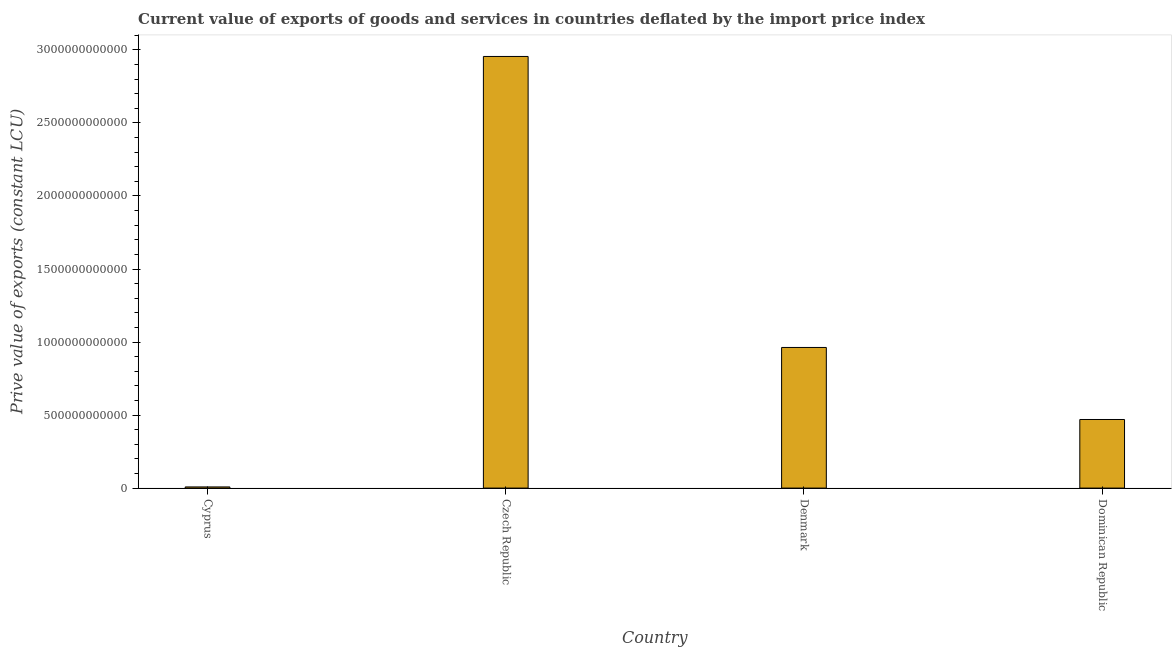Does the graph contain any zero values?
Make the answer very short. No. What is the title of the graph?
Offer a very short reply. Current value of exports of goods and services in countries deflated by the import price index. What is the label or title of the Y-axis?
Ensure brevity in your answer.  Prive value of exports (constant LCU). What is the price value of exports in Dominican Republic?
Keep it short and to the point. 4.70e+11. Across all countries, what is the maximum price value of exports?
Make the answer very short. 2.96e+12. Across all countries, what is the minimum price value of exports?
Your response must be concise. 7.92e+09. In which country was the price value of exports maximum?
Offer a terse response. Czech Republic. In which country was the price value of exports minimum?
Your answer should be compact. Cyprus. What is the sum of the price value of exports?
Make the answer very short. 4.40e+12. What is the difference between the price value of exports in Cyprus and Denmark?
Your response must be concise. -9.55e+11. What is the average price value of exports per country?
Offer a very short reply. 1.10e+12. What is the median price value of exports?
Your answer should be very brief. 7.16e+11. In how many countries, is the price value of exports greater than 1000000000000 LCU?
Make the answer very short. 1. What is the ratio of the price value of exports in Cyprus to that in Denmark?
Ensure brevity in your answer.  0.01. Is the price value of exports in Cyprus less than that in Dominican Republic?
Ensure brevity in your answer.  Yes. Is the difference between the price value of exports in Czech Republic and Denmark greater than the difference between any two countries?
Ensure brevity in your answer.  No. What is the difference between the highest and the second highest price value of exports?
Your response must be concise. 1.99e+12. Is the sum of the price value of exports in Denmark and Dominican Republic greater than the maximum price value of exports across all countries?
Your answer should be compact. No. What is the difference between the highest and the lowest price value of exports?
Your answer should be very brief. 2.95e+12. Are all the bars in the graph horizontal?
Provide a short and direct response. No. How many countries are there in the graph?
Give a very brief answer. 4. What is the difference between two consecutive major ticks on the Y-axis?
Ensure brevity in your answer.  5.00e+11. What is the Prive value of exports (constant LCU) of Cyprus?
Ensure brevity in your answer.  7.92e+09. What is the Prive value of exports (constant LCU) of Czech Republic?
Offer a very short reply. 2.96e+12. What is the Prive value of exports (constant LCU) in Denmark?
Keep it short and to the point. 9.63e+11. What is the Prive value of exports (constant LCU) in Dominican Republic?
Ensure brevity in your answer.  4.70e+11. What is the difference between the Prive value of exports (constant LCU) in Cyprus and Czech Republic?
Ensure brevity in your answer.  -2.95e+12. What is the difference between the Prive value of exports (constant LCU) in Cyprus and Denmark?
Give a very brief answer. -9.55e+11. What is the difference between the Prive value of exports (constant LCU) in Cyprus and Dominican Republic?
Your answer should be compact. -4.62e+11. What is the difference between the Prive value of exports (constant LCU) in Czech Republic and Denmark?
Your response must be concise. 1.99e+12. What is the difference between the Prive value of exports (constant LCU) in Czech Republic and Dominican Republic?
Your response must be concise. 2.49e+12. What is the difference between the Prive value of exports (constant LCU) in Denmark and Dominican Republic?
Your response must be concise. 4.93e+11. What is the ratio of the Prive value of exports (constant LCU) in Cyprus to that in Czech Republic?
Offer a very short reply. 0. What is the ratio of the Prive value of exports (constant LCU) in Cyprus to that in Denmark?
Provide a succinct answer. 0.01. What is the ratio of the Prive value of exports (constant LCU) in Cyprus to that in Dominican Republic?
Give a very brief answer. 0.02. What is the ratio of the Prive value of exports (constant LCU) in Czech Republic to that in Denmark?
Give a very brief answer. 3.07. What is the ratio of the Prive value of exports (constant LCU) in Czech Republic to that in Dominican Republic?
Give a very brief answer. 6.29. What is the ratio of the Prive value of exports (constant LCU) in Denmark to that in Dominican Republic?
Offer a terse response. 2.05. 